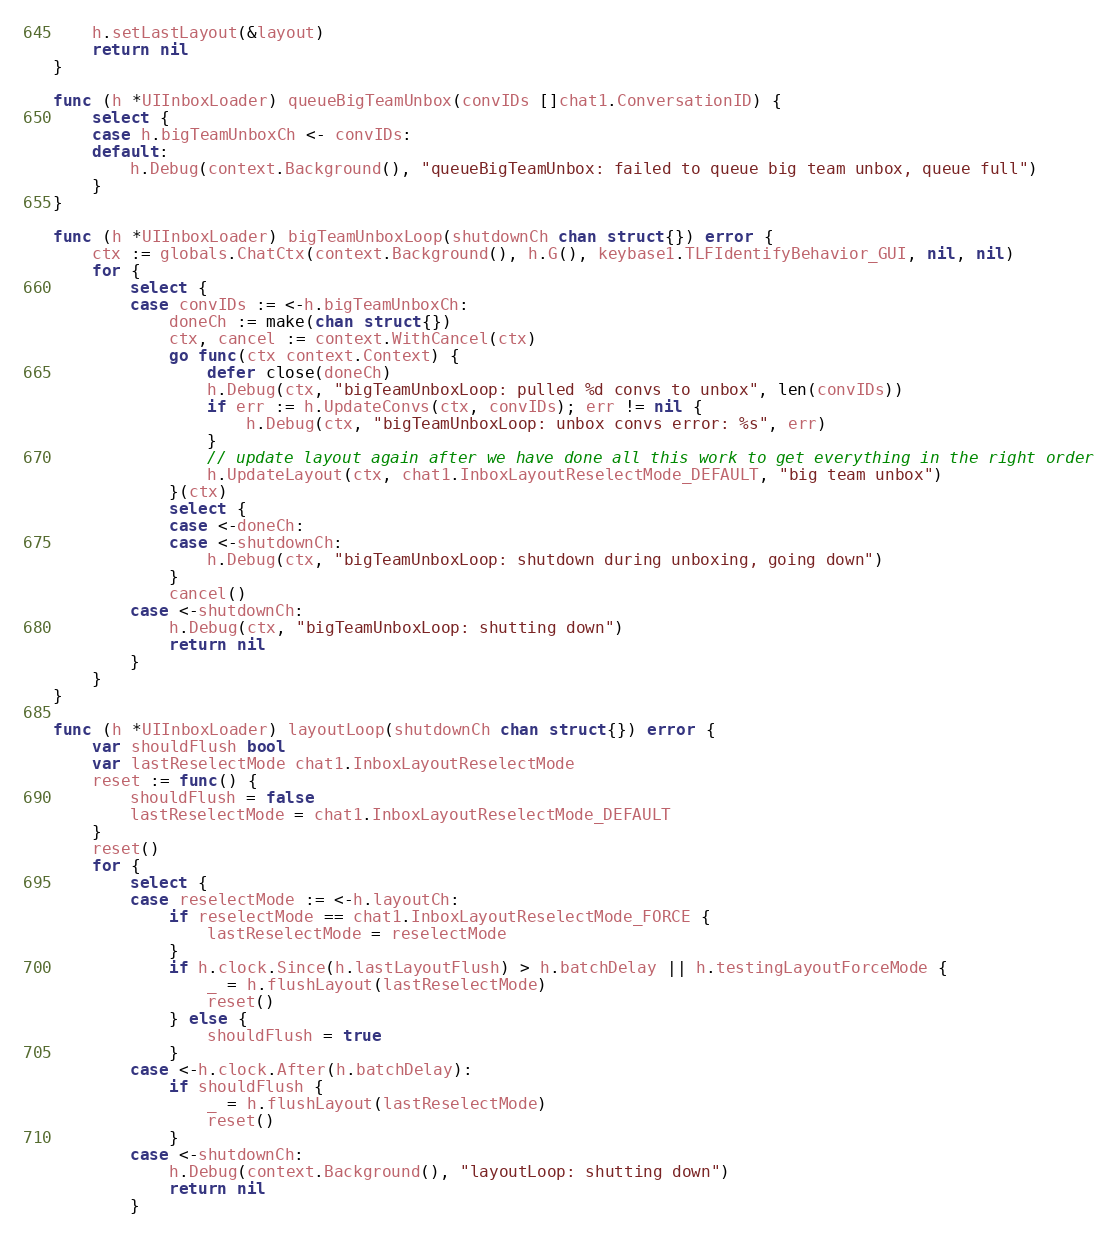Convert code to text. <code><loc_0><loc_0><loc_500><loc_500><_Go_>	h.setLastLayout(&layout)
	return nil
}

func (h *UIInboxLoader) queueBigTeamUnbox(convIDs []chat1.ConversationID) {
	select {
	case h.bigTeamUnboxCh <- convIDs:
	default:
		h.Debug(context.Background(), "queueBigTeamUnbox: failed to queue big team unbox, queue full")
	}
}

func (h *UIInboxLoader) bigTeamUnboxLoop(shutdownCh chan struct{}) error {
	ctx := globals.ChatCtx(context.Background(), h.G(), keybase1.TLFIdentifyBehavior_GUI, nil, nil)
	for {
		select {
		case convIDs := <-h.bigTeamUnboxCh:
			doneCh := make(chan struct{})
			ctx, cancel := context.WithCancel(ctx)
			go func(ctx context.Context) {
				defer close(doneCh)
				h.Debug(ctx, "bigTeamUnboxLoop: pulled %d convs to unbox", len(convIDs))
				if err := h.UpdateConvs(ctx, convIDs); err != nil {
					h.Debug(ctx, "bigTeamUnboxLoop: unbox convs error: %s", err)
				}
				// update layout again after we have done all this work to get everything in the right order
				h.UpdateLayout(ctx, chat1.InboxLayoutReselectMode_DEFAULT, "big team unbox")
			}(ctx)
			select {
			case <-doneCh:
			case <-shutdownCh:
				h.Debug(ctx, "bigTeamUnboxLoop: shutdown during unboxing, going down")
			}
			cancel()
		case <-shutdownCh:
			h.Debug(ctx, "bigTeamUnboxLoop: shutting down")
			return nil
		}
	}
}

func (h *UIInboxLoader) layoutLoop(shutdownCh chan struct{}) error {
	var shouldFlush bool
	var lastReselectMode chat1.InboxLayoutReselectMode
	reset := func() {
		shouldFlush = false
		lastReselectMode = chat1.InboxLayoutReselectMode_DEFAULT
	}
	reset()
	for {
		select {
		case reselectMode := <-h.layoutCh:
			if reselectMode == chat1.InboxLayoutReselectMode_FORCE {
				lastReselectMode = reselectMode
			}
			if h.clock.Since(h.lastLayoutFlush) > h.batchDelay || h.testingLayoutForceMode {
				_ = h.flushLayout(lastReselectMode)
				reset()
			} else {
				shouldFlush = true
			}
		case <-h.clock.After(h.batchDelay):
			if shouldFlush {
				_ = h.flushLayout(lastReselectMode)
				reset()
			}
		case <-shutdownCh:
			h.Debug(context.Background(), "layoutLoop: shutting down")
			return nil
		}</code> 